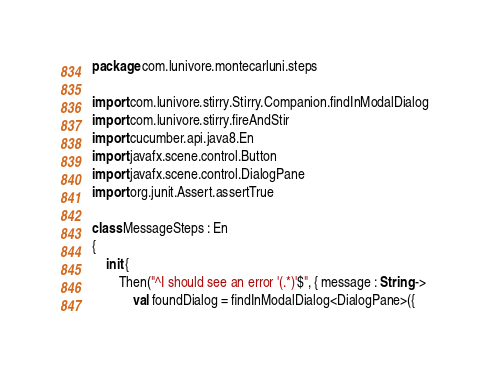<code> <loc_0><loc_0><loc_500><loc_500><_Kotlin_>package com.lunivore.montecarluni.steps

import com.lunivore.stirry.Stirry.Companion.findInModalDialog
import com.lunivore.stirry.fireAndStir
import cucumber.api.java8.En
import javafx.scene.control.Button
import javafx.scene.control.DialogPane
import org.junit.Assert.assertTrue

class MessageSteps : En
{
    init {
        Then("^I should see an error '(.*)'$", { message : String ->
            val foundDialog = findInModalDialog<DialogPane>({</code> 